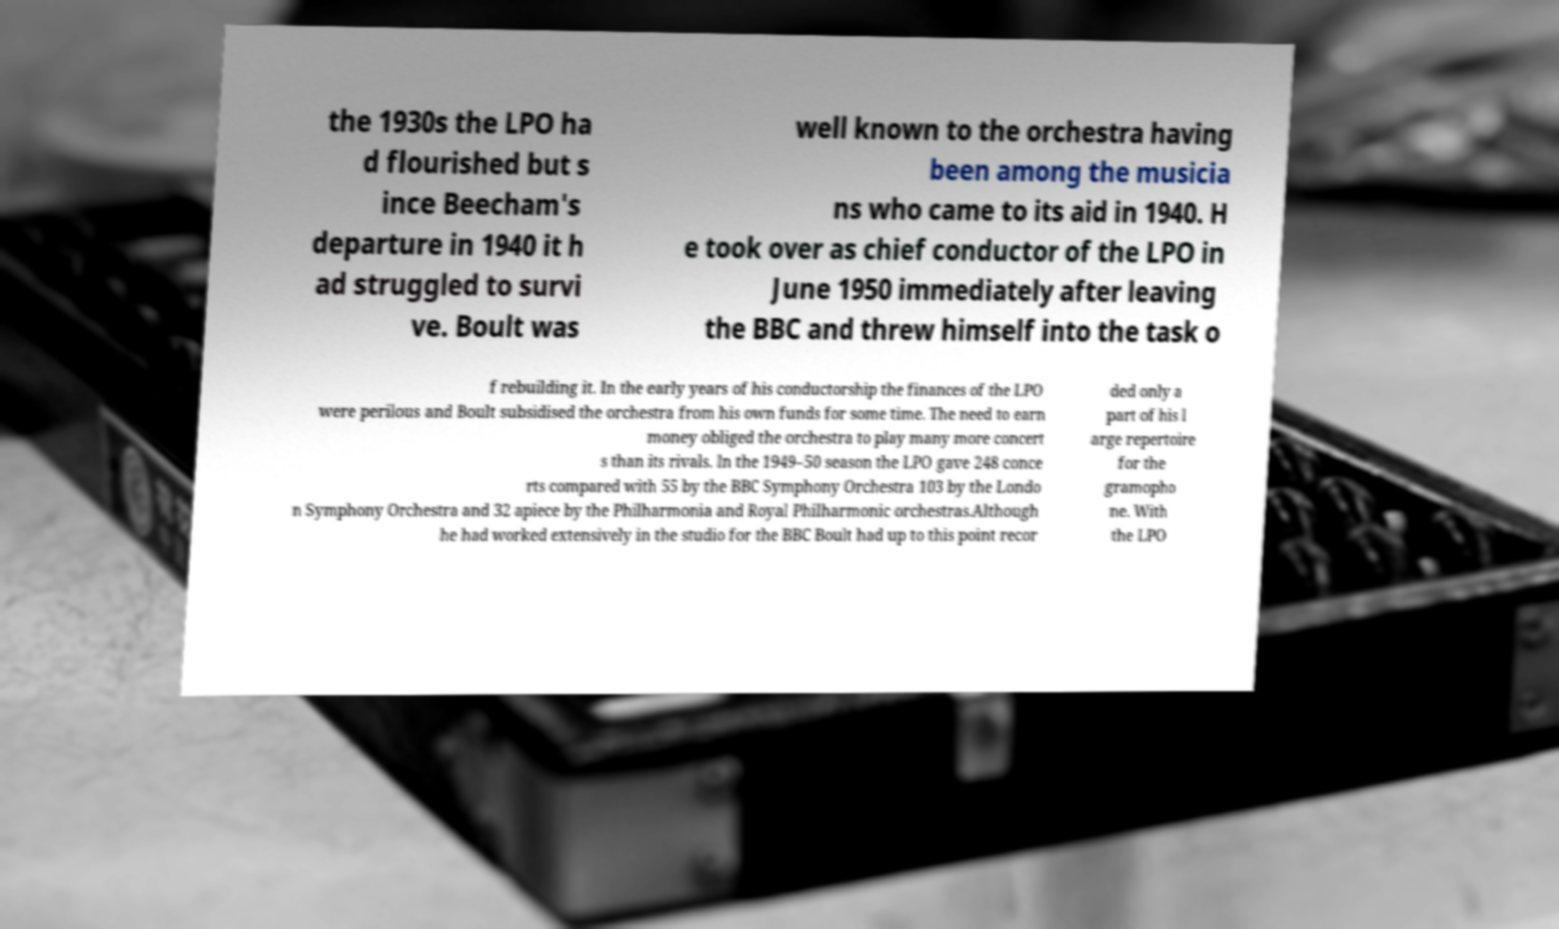Please read and relay the text visible in this image. What does it say? the 1930s the LPO ha d flourished but s ince Beecham's departure in 1940 it h ad struggled to survi ve. Boult was well known to the orchestra having been among the musicia ns who came to its aid in 1940. H e took over as chief conductor of the LPO in June 1950 immediately after leaving the BBC and threw himself into the task o f rebuilding it. In the early years of his conductorship the finances of the LPO were perilous and Boult subsidised the orchestra from his own funds for some time. The need to earn money obliged the orchestra to play many more concert s than its rivals. In the 1949–50 season the LPO gave 248 conce rts compared with 55 by the BBC Symphony Orchestra 103 by the Londo n Symphony Orchestra and 32 apiece by the Philharmonia and Royal Philharmonic orchestras.Although he had worked extensively in the studio for the BBC Boult had up to this point recor ded only a part of his l arge repertoire for the gramopho ne. With the LPO 